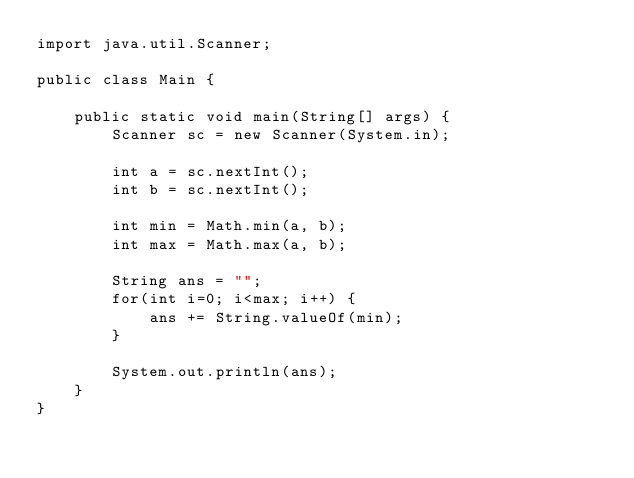Convert code to text. <code><loc_0><loc_0><loc_500><loc_500><_Java_>import java.util.Scanner;

public class Main {

    public static void main(String[] args) {
        Scanner sc = new Scanner(System.in);

        int a = sc.nextInt();
        int b = sc.nextInt();
        
        int min = Math.min(a, b);
        int max = Math.max(a, b);
        
        String ans = "";
        for(int i=0; i<max; i++) {
            ans += String.valueOf(min);
        }
        
        System.out.println(ans);
    }
}
</code> 